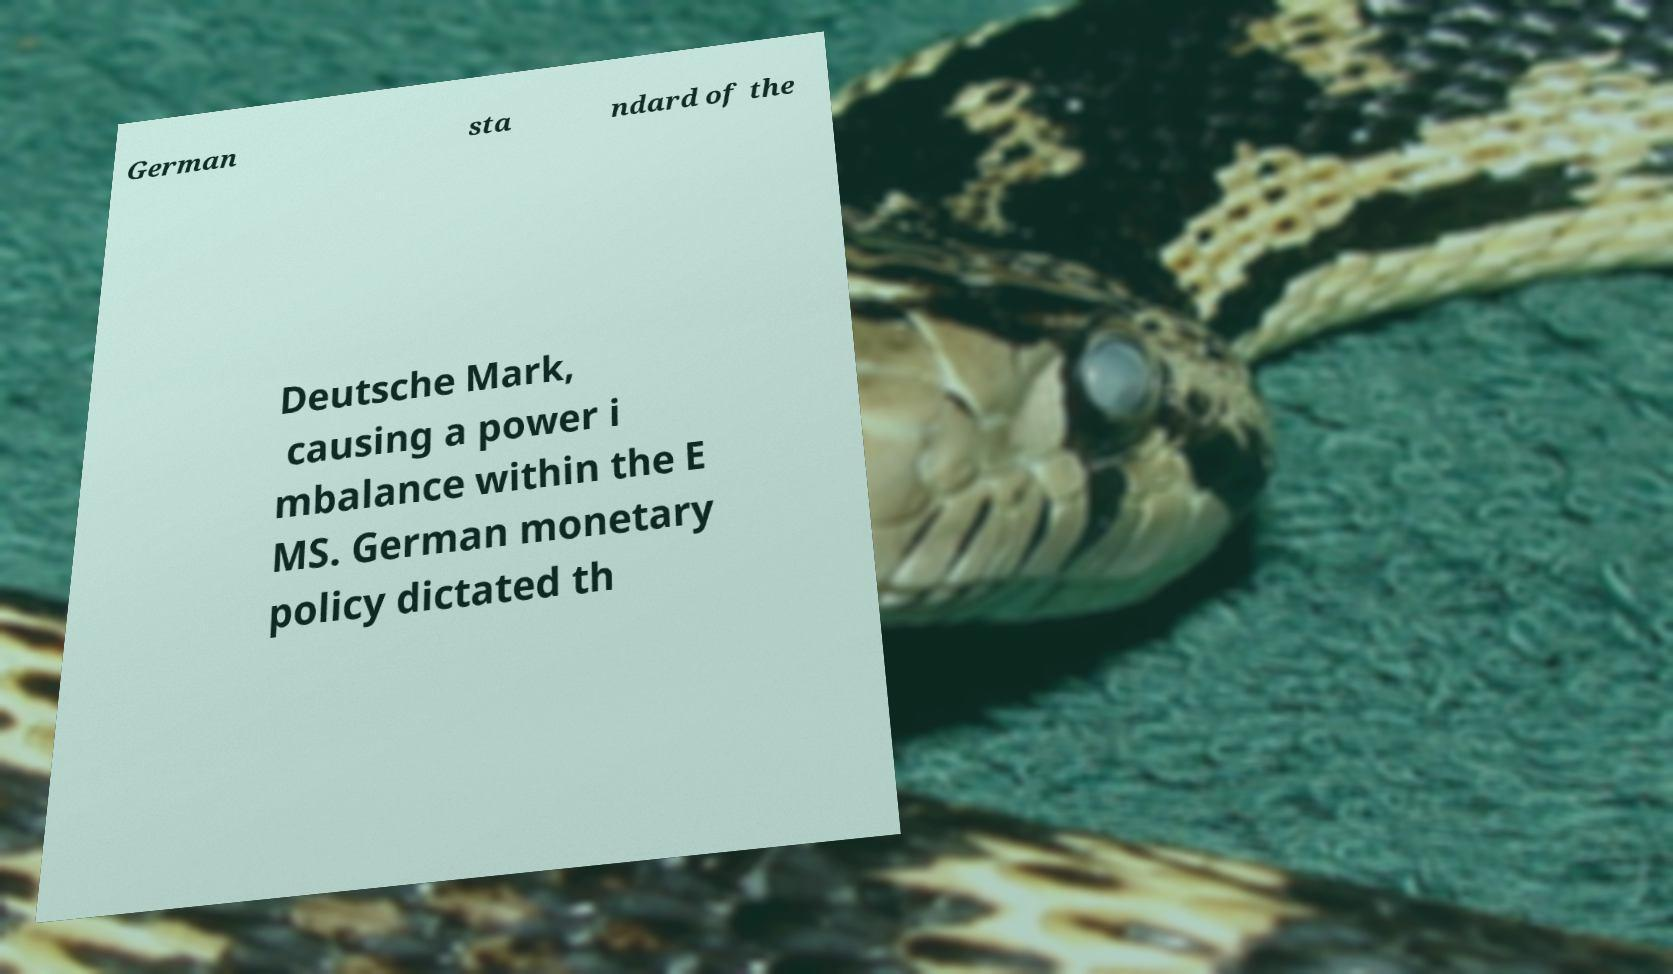I need the written content from this picture converted into text. Can you do that? German sta ndard of the Deutsche Mark, causing a power i mbalance within the E MS. German monetary policy dictated th 